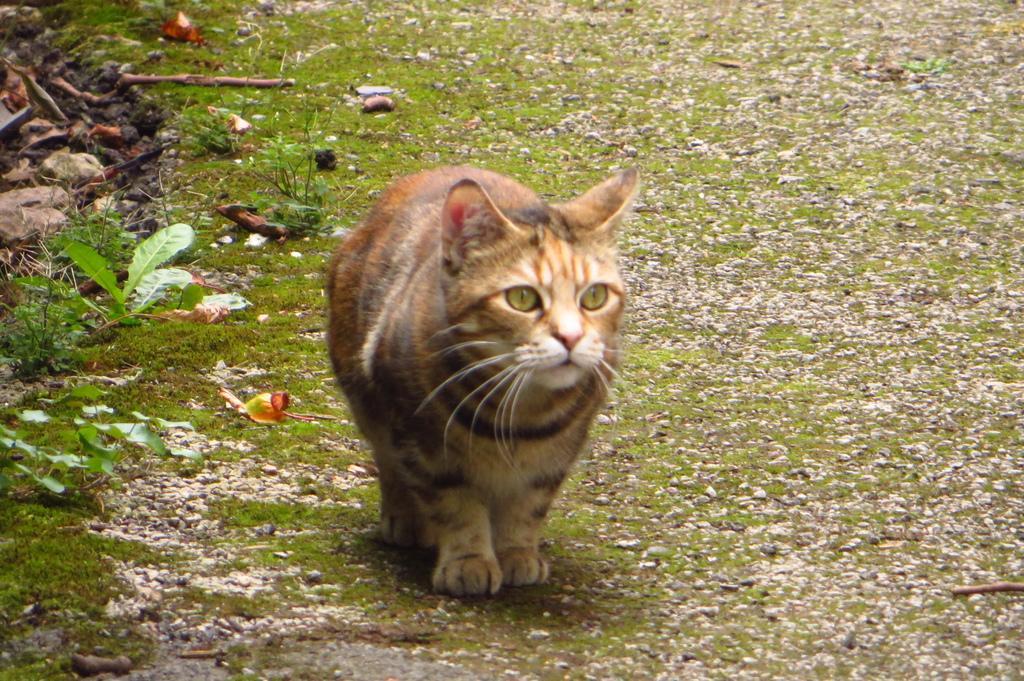How would you summarize this image in a sentence or two? In the picture there is a cat walking on the grass and beside the cat there are few leaves and some stones. 